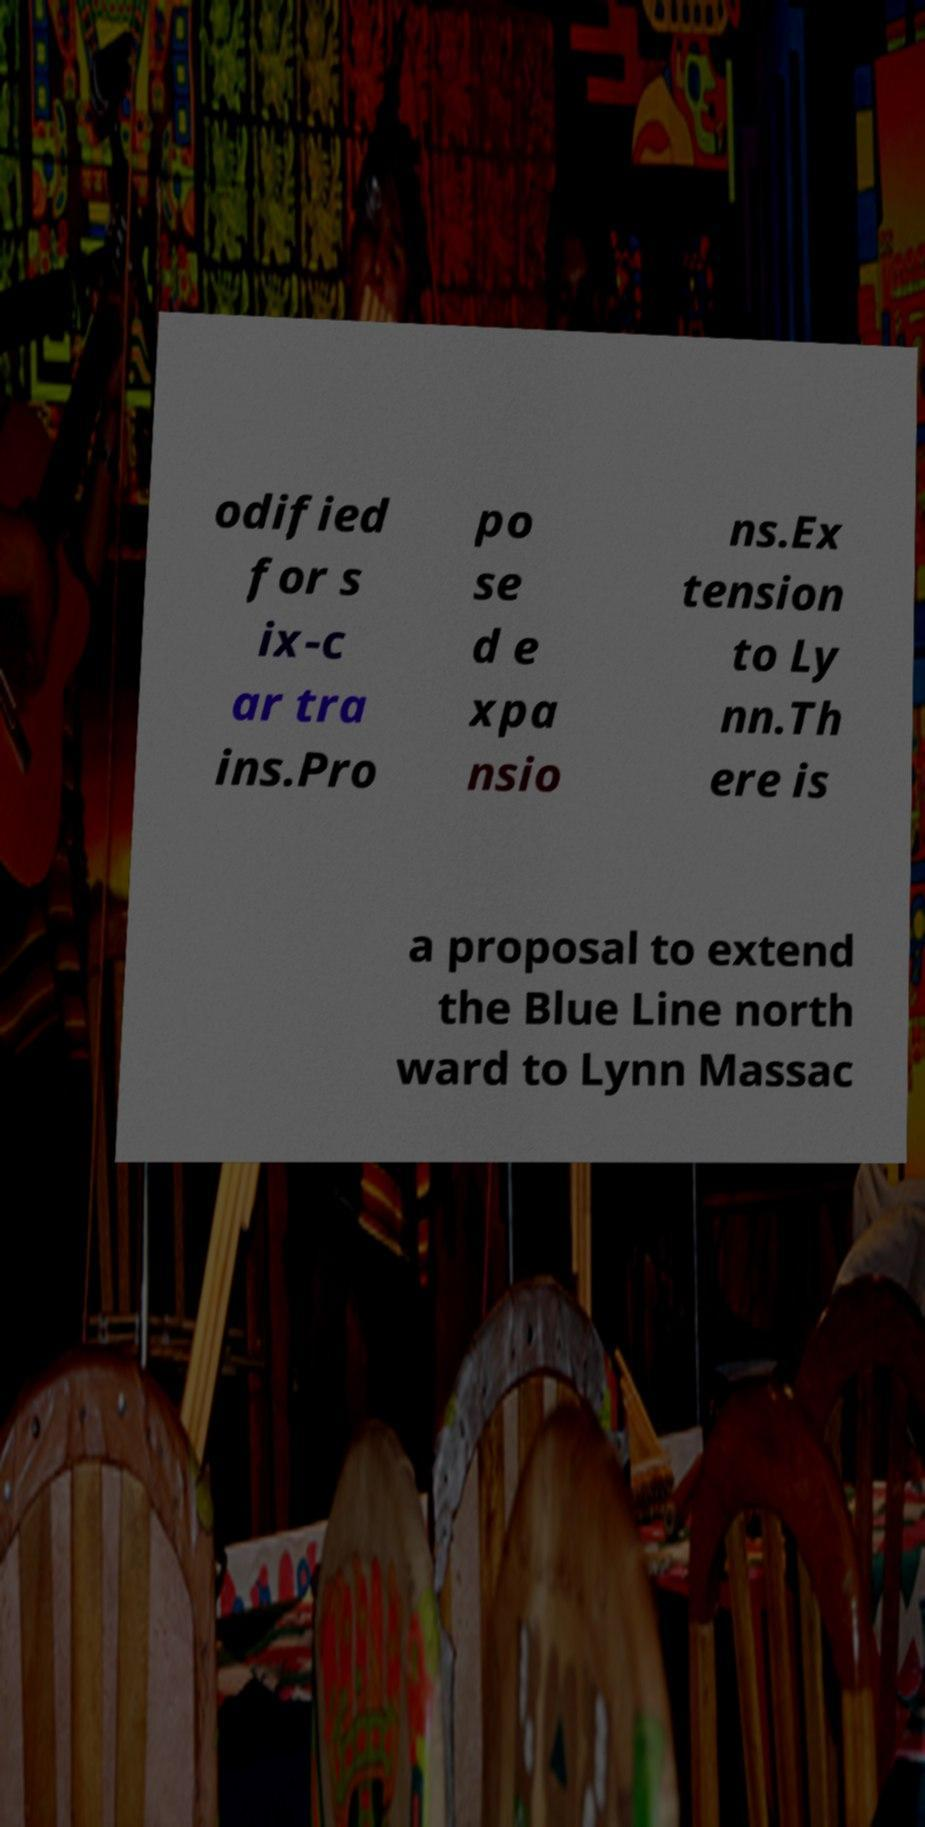Please identify and transcribe the text found in this image. odified for s ix-c ar tra ins.Pro po se d e xpa nsio ns.Ex tension to Ly nn.Th ere is a proposal to extend the Blue Line north ward to Lynn Massac 